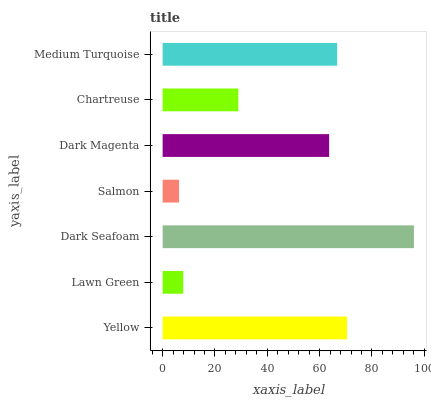Is Salmon the minimum?
Answer yes or no. Yes. Is Dark Seafoam the maximum?
Answer yes or no. Yes. Is Lawn Green the minimum?
Answer yes or no. No. Is Lawn Green the maximum?
Answer yes or no. No. Is Yellow greater than Lawn Green?
Answer yes or no. Yes. Is Lawn Green less than Yellow?
Answer yes or no. Yes. Is Lawn Green greater than Yellow?
Answer yes or no. No. Is Yellow less than Lawn Green?
Answer yes or no. No. Is Dark Magenta the high median?
Answer yes or no. Yes. Is Dark Magenta the low median?
Answer yes or no. Yes. Is Lawn Green the high median?
Answer yes or no. No. Is Medium Turquoise the low median?
Answer yes or no. No. 